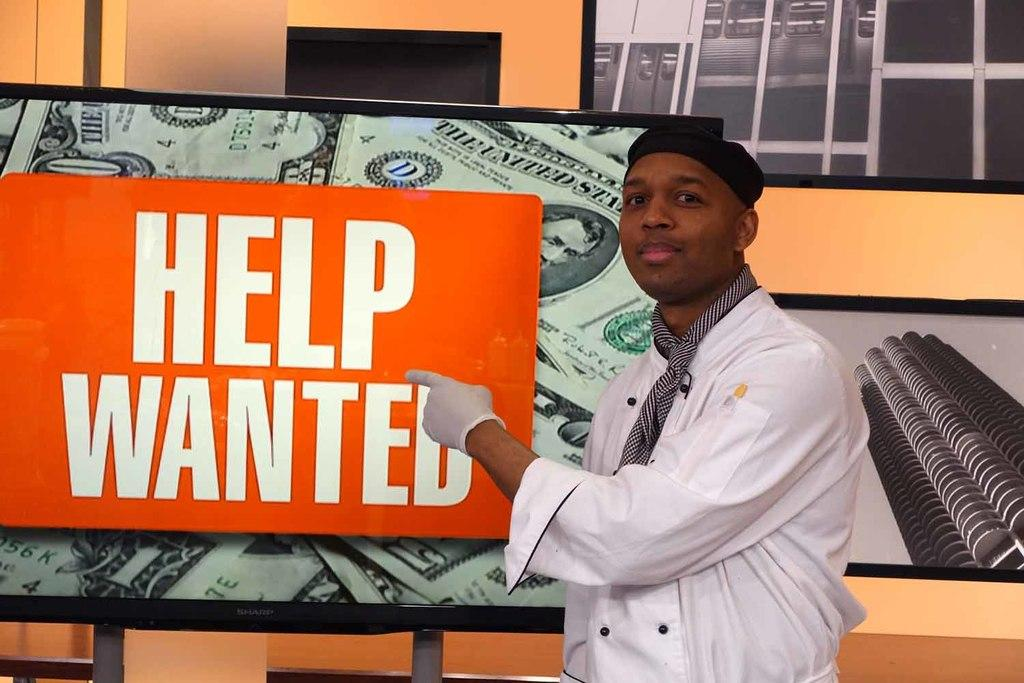What is the main subject of the image? There is a person in the image. What else can be seen in the image besides the person? There are screens in the image. What type of machine is visible on the coast in the image? There is no machine or coast present in the image; it only features a person and screens. 